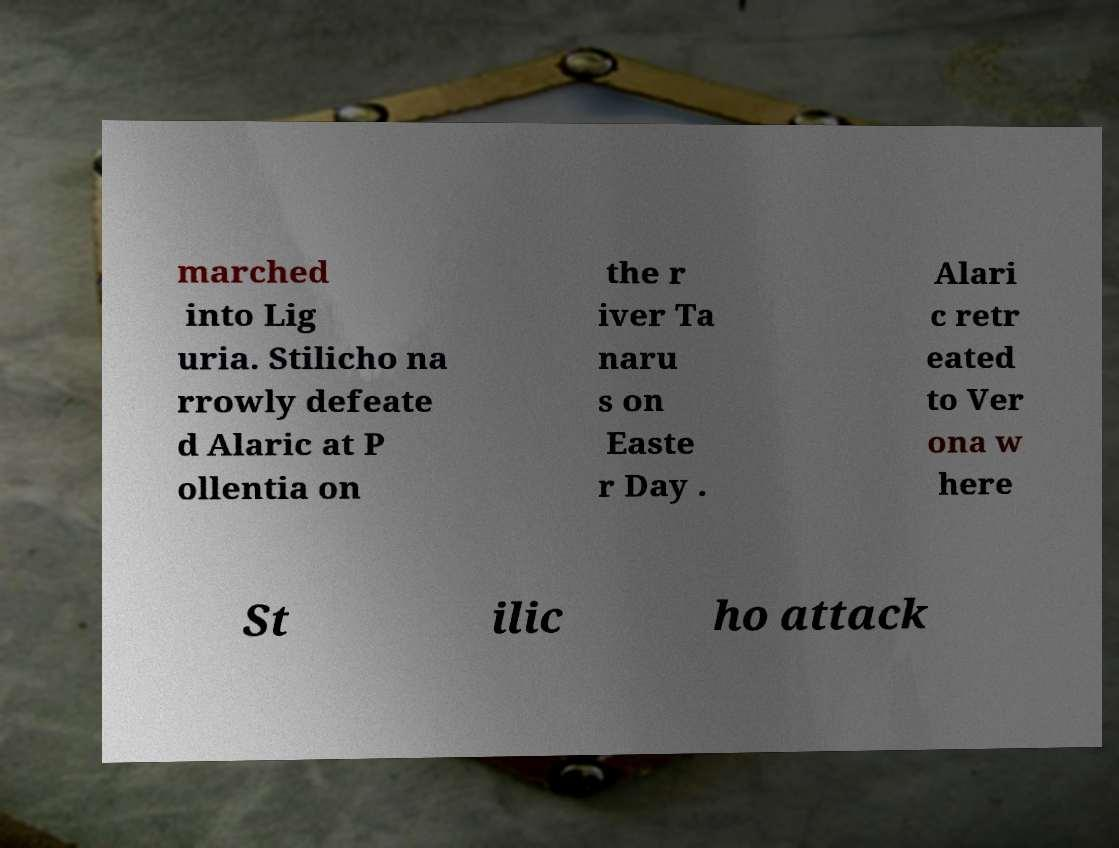Can you accurately transcribe the text from the provided image for me? marched into Lig uria. Stilicho na rrowly defeate d Alaric at P ollentia on the r iver Ta naru s on Easte r Day . Alari c retr eated to Ver ona w here St ilic ho attack 